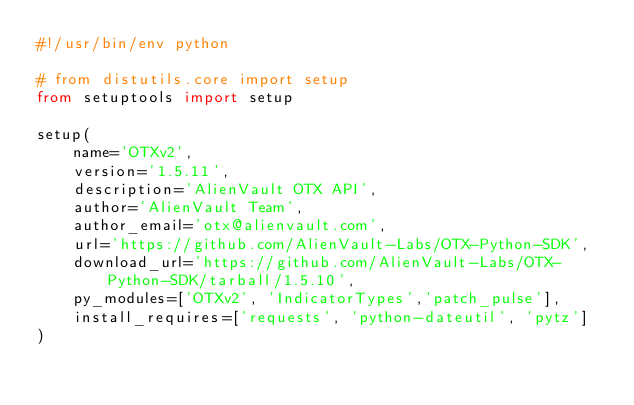<code> <loc_0><loc_0><loc_500><loc_500><_Python_>#!/usr/bin/env python

# from distutils.core import setup
from setuptools import setup

setup(
    name='OTXv2',
    version='1.5.11',
    description='AlienVault OTX API',
    author='AlienVault Team',
    author_email='otx@alienvault.com',
    url='https://github.com/AlienVault-Labs/OTX-Python-SDK',
    download_url='https://github.com/AlienVault-Labs/OTX-Python-SDK/tarball/1.5.10',
    py_modules=['OTXv2', 'IndicatorTypes','patch_pulse'],
    install_requires=['requests', 'python-dateutil', 'pytz']
)
</code> 